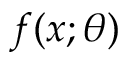<formula> <loc_0><loc_0><loc_500><loc_500>f ( x ; \theta )</formula> 